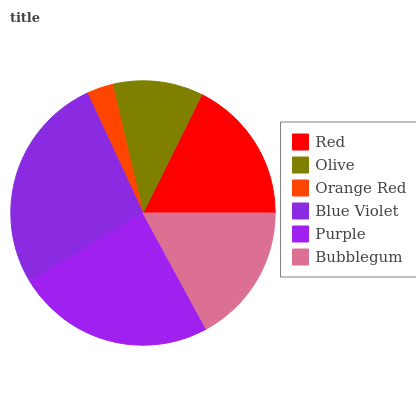Is Orange Red the minimum?
Answer yes or no. Yes. Is Blue Violet the maximum?
Answer yes or no. Yes. Is Olive the minimum?
Answer yes or no. No. Is Olive the maximum?
Answer yes or no. No. Is Red greater than Olive?
Answer yes or no. Yes. Is Olive less than Red?
Answer yes or no. Yes. Is Olive greater than Red?
Answer yes or no. No. Is Red less than Olive?
Answer yes or no. No. Is Red the high median?
Answer yes or no. Yes. Is Bubblegum the low median?
Answer yes or no. Yes. Is Purple the high median?
Answer yes or no. No. Is Blue Violet the low median?
Answer yes or no. No. 